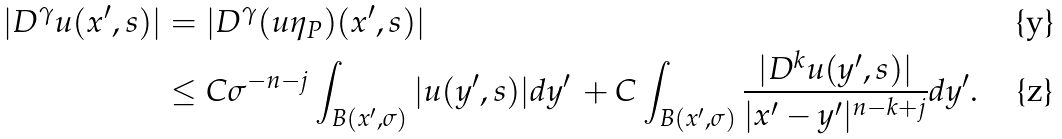Convert formula to latex. <formula><loc_0><loc_0><loc_500><loc_500>| D ^ { \gamma } u ( x ^ { \prime } , s ) | & = | D ^ { \gamma } ( u \eta _ { P } ) ( x ^ { \prime } , s ) | \\ & \leq C \sigma ^ { - n - j } \int _ { B ( x ^ { \prime } , \sigma ) } | u ( y ^ { \prime } , s ) | d y ^ { \prime } \, + C \int _ { B ( x ^ { \prime } , \sigma ) } \frac { | D ^ { k } u ( y ^ { \prime } , s ) | } { | x ^ { \prime } - y ^ { \prime } | ^ { n - k + j } } d y ^ { \prime } .</formula> 